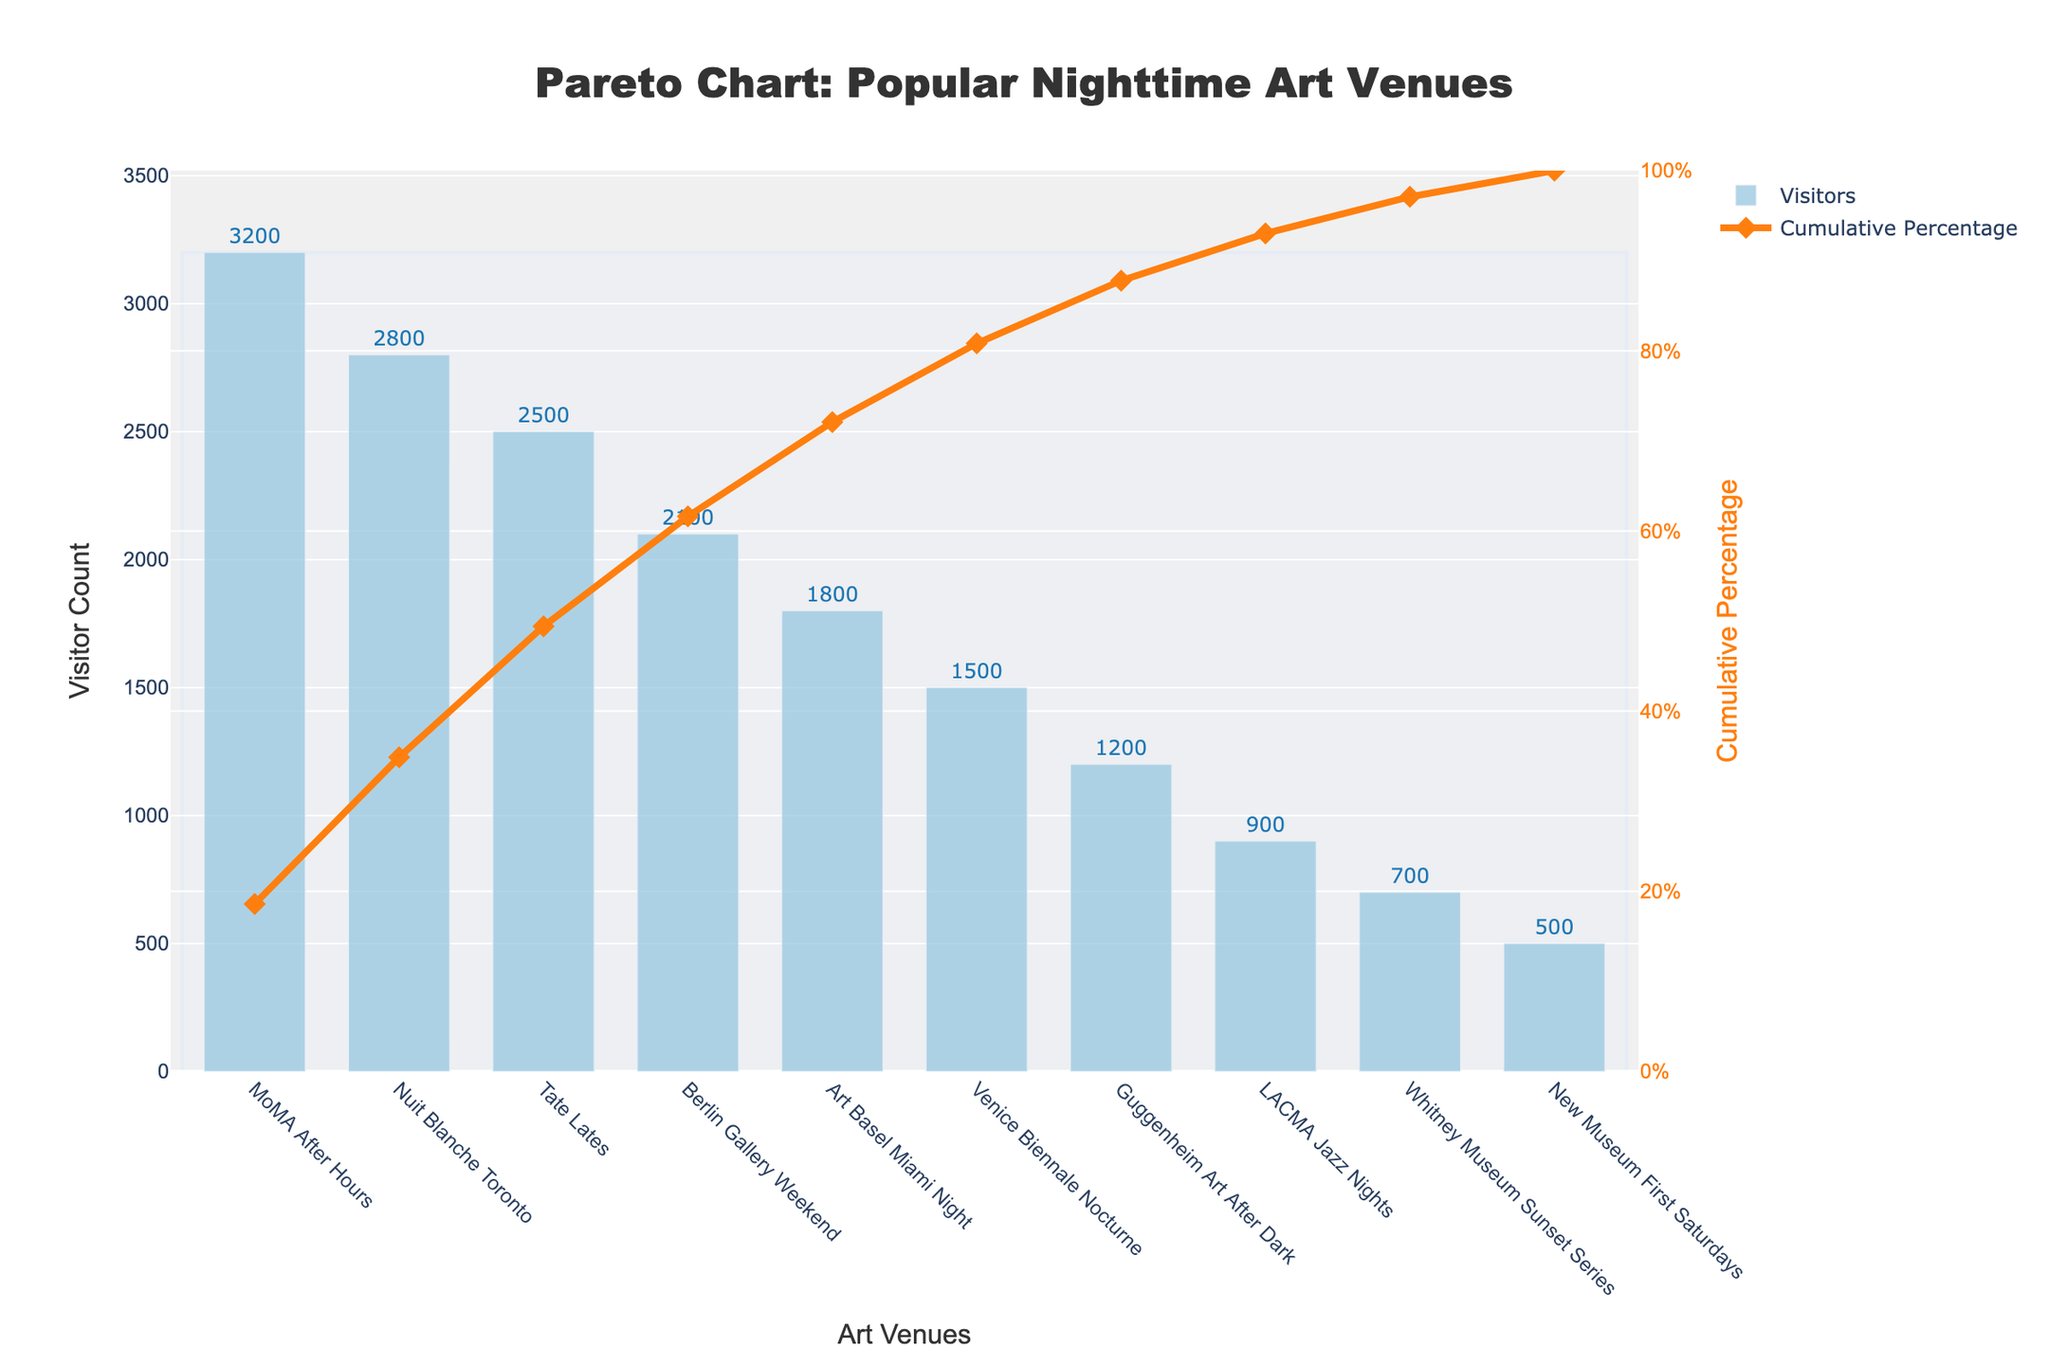What's the title of the figure? The title is placed at the top of the figure. It summarizes the main topic of the plot.
Answer: Pareto Chart: Popular Nighttime Art Venues Which venue has the highest visitor count? By looking at the height of the bars, the tallest one indicates the venue with the highest visitor count.
Answer: MoMA After Hours How many venues have more than 2000 visitors? Scan the bars and count how many have heights greater than 2000 on the y-axis.
Answer: 4 What's the cumulative percentage for Nuit Blanche Toronto? Refer to the scatter line (cumulative percentage) and find the value where it aligns with Nuit Blanche Toronto on the x-axis.
Answer: 37.4% Which venue has the lowest visitor count and what is it? Look for the shortest bar and read its label along with the visitor count text displayed on or above the bar.
Answer: New Museum First Saturdays, 500 What's the total visitor count for Tate Lates, Berlin Gallery Weekend, and Art Basel Miami Night? Add the visitors for each of these venues: Tate Lates (2500), Berlin Gallery Weekend (2100), and Art Basel Miami Night (1800).
Answer: 6400 Compare MoMA After Hours and Tate Lates in terms of visitor count. How much more does MoMA After Hours have? Subtract the visitor count of Tate Lates from MoMA After Hours: 3200 - 2500.
Answer: 700 After how many venues does the cumulative percentage surpass 50%? Identify the point on the scatter line where it crosses the 50% mark and count the number of venues from left to that point.
Answer: 3 What's the average visitor count of the top 3 venues? Add the visitor counts of the top 3 venues (3200 + 2800 + 2500) and divide by 3.
Answer: 2833.33 What's the cumulative percentage for all 10 venues? The cumulative percentage line ends at 100%, confirming the total representation of all venues.
Answer: 100% 